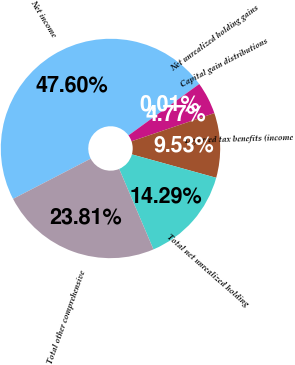<chart> <loc_0><loc_0><loc_500><loc_500><pie_chart><fcel>Net income<fcel>Net unrealized holding gains<fcel>Capital gain distributions<fcel>Deferred tax benefits (income<fcel>Total net unrealized holding<fcel>Total other comprehensive<nl><fcel>47.61%<fcel>0.01%<fcel>4.77%<fcel>9.53%<fcel>14.29%<fcel>23.81%<nl></chart> 